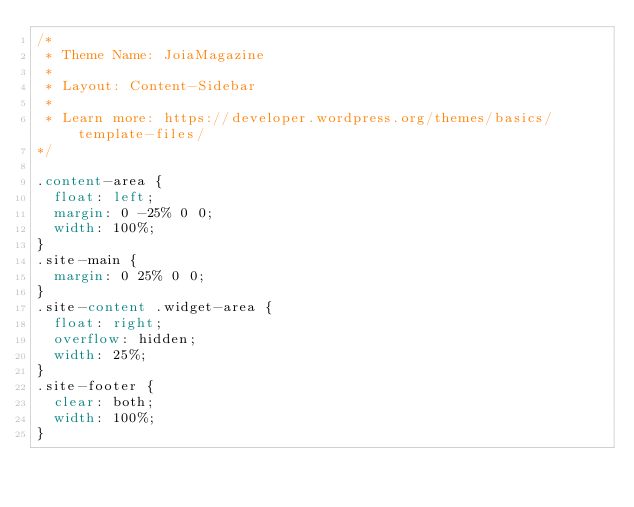Convert code to text. <code><loc_0><loc_0><loc_500><loc_500><_CSS_>/*
 * Theme Name: JoiaMagazine
 *
 * Layout: Content-Sidebar
 *
 * Learn more: https://developer.wordpress.org/themes/basics/template-files/
*/

.content-area {
	float: left;
	margin: 0 -25% 0 0;
	width: 100%;
}
.site-main {
	margin: 0 25% 0 0;
}
.site-content .widget-area {
	float: right;
	overflow: hidden;
	width: 25%;
}
.site-footer {
	clear: both;
	width: 100%;
}</code> 